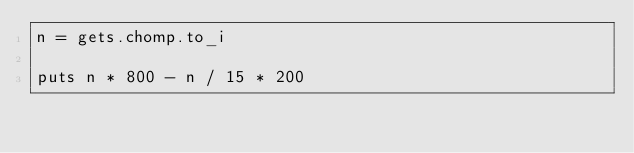<code> <loc_0><loc_0><loc_500><loc_500><_Ruby_>n = gets.chomp.to_i

puts n * 800 - n / 15 * 200</code> 